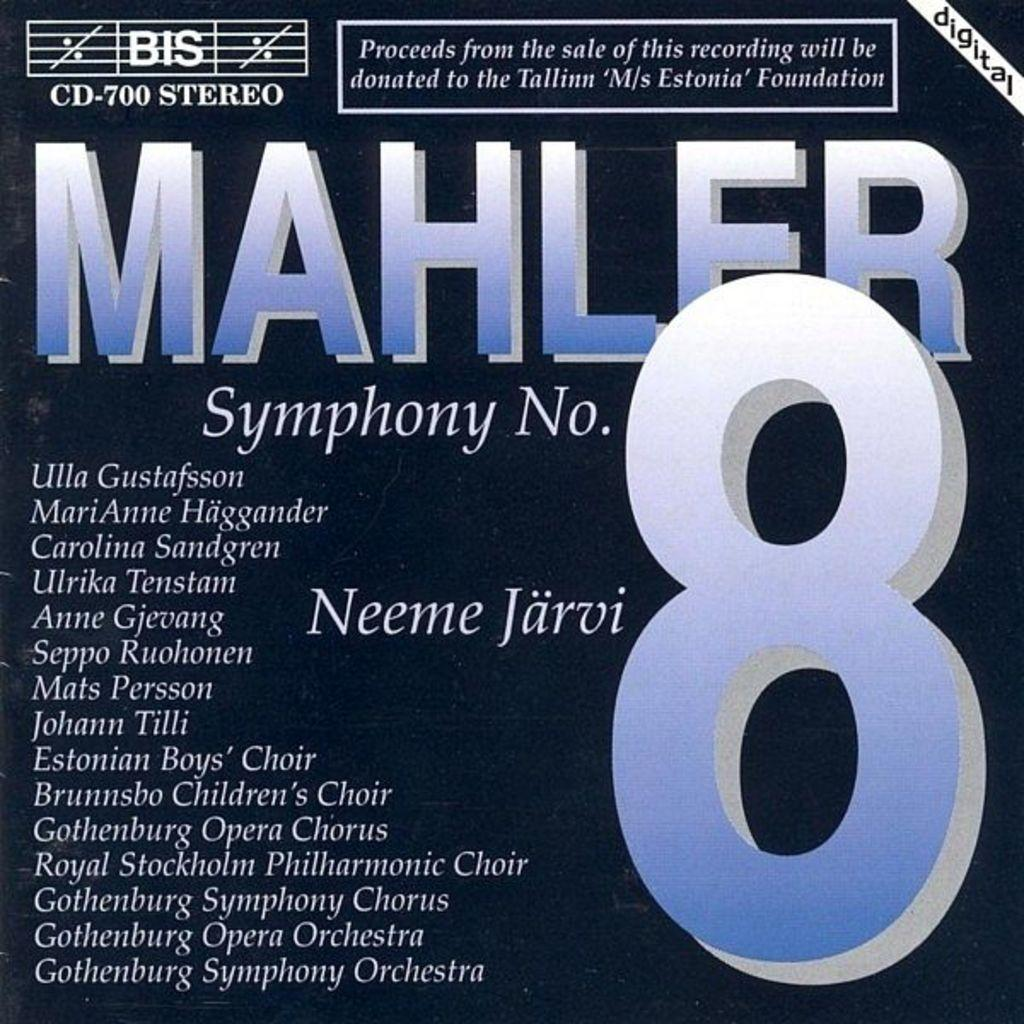<image>
Summarize the visual content of the image. Proceeds from the sale of this Mahler 8 recording are being given to a foundation. 